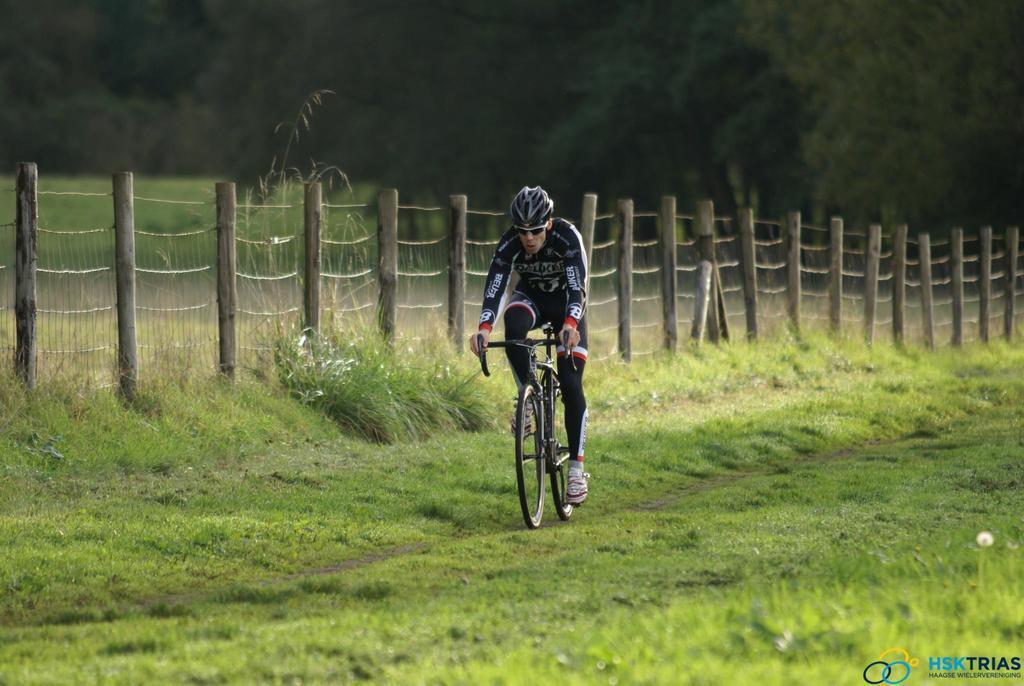Can you describe this image briefly? This image is taken outdoors. At the bottom of the image there is a ground with grass on it. In the background there are many trees and there are a few plans. There is a fence. In the middle of the image a man is riding a bicycle. 